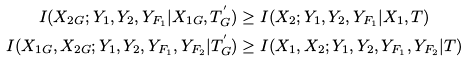<formula> <loc_0><loc_0><loc_500><loc_500>I ( X _ { 2 G } ; Y _ { 1 } , Y _ { 2 } , Y _ { F _ { 1 } } | X _ { 1 G } , T ^ { ^ { \prime } } _ { G } ) & \geq I ( X _ { 2 } ; Y _ { 1 } , Y _ { 2 } , Y _ { F _ { 1 } } | X _ { 1 } , T ) \\ I ( X _ { 1 G } , X _ { 2 G } ; Y _ { 1 } , Y _ { 2 } , Y _ { F _ { 1 } } , Y _ { F _ { 2 } } | T ^ { ^ { \prime } } _ { G } ) & \geq I ( X _ { 1 } , X _ { 2 } ; Y _ { 1 } , Y _ { 2 } , Y _ { F _ { 1 } } , Y _ { F _ { 2 } } | T )</formula> 